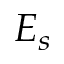Convert formula to latex. <formula><loc_0><loc_0><loc_500><loc_500>E _ { s }</formula> 